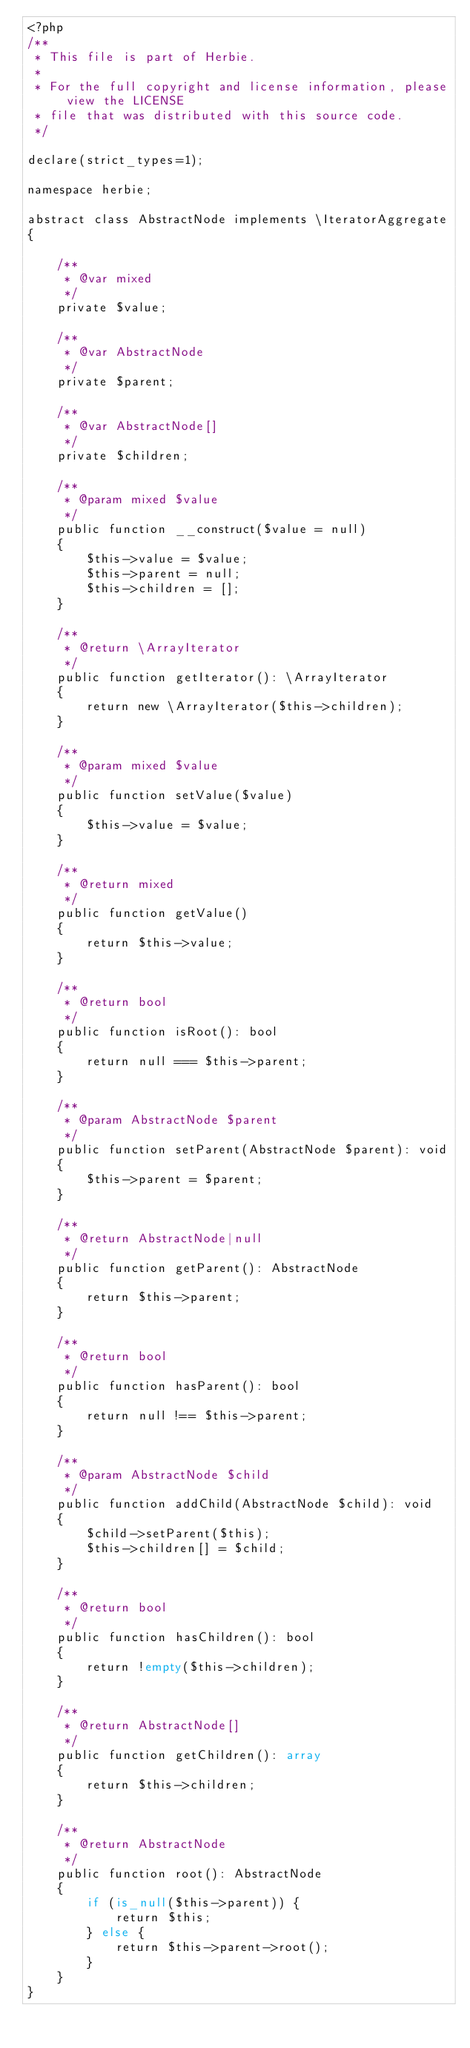Convert code to text. <code><loc_0><loc_0><loc_500><loc_500><_PHP_><?php
/**
 * This file is part of Herbie.
 *
 * For the full copyright and license information, please view the LICENSE
 * file that was distributed with this source code.
 */

declare(strict_types=1);

namespace herbie;

abstract class AbstractNode implements \IteratorAggregate
{

    /**
     * @var mixed
     */
    private $value;

    /**
     * @var AbstractNode
     */
    private $parent;

    /**
     * @var AbstractNode[]
     */
    private $children;

    /**
     * @param mixed $value
     */
    public function __construct($value = null)
    {
        $this->value = $value;
        $this->parent = null;
        $this->children = [];
    }

    /**
     * @return \ArrayIterator
     */
    public function getIterator(): \ArrayIterator
    {
        return new \ArrayIterator($this->children);
    }

    /**
     * @param mixed $value
     */
    public function setValue($value)
    {
        $this->value = $value;
    }

    /**
     * @return mixed
     */
    public function getValue()
    {
        return $this->value;
    }

    /**
     * @return bool
     */
    public function isRoot(): bool
    {
        return null === $this->parent;
    }

    /**
     * @param AbstractNode $parent
     */
    public function setParent(AbstractNode $parent): void
    {
        $this->parent = $parent;
    }

    /**
     * @return AbstractNode|null
     */
    public function getParent(): AbstractNode
    {
        return $this->parent;
    }

    /**
     * @return bool
     */
    public function hasParent(): bool
    {
        return null !== $this->parent;
    }

    /**
     * @param AbstractNode $child
     */
    public function addChild(AbstractNode $child): void
    {
        $child->setParent($this);
        $this->children[] = $child;
    }

    /**
     * @return bool
     */
    public function hasChildren(): bool
    {
        return !empty($this->children);
    }

    /**
     * @return AbstractNode[]
     */
    public function getChildren(): array
    {
        return $this->children;
    }

    /**
     * @return AbstractNode
     */
    public function root(): AbstractNode
    {
        if (is_null($this->parent)) {
            return $this;
        } else {
            return $this->parent->root();
        }
    }
}
</code> 